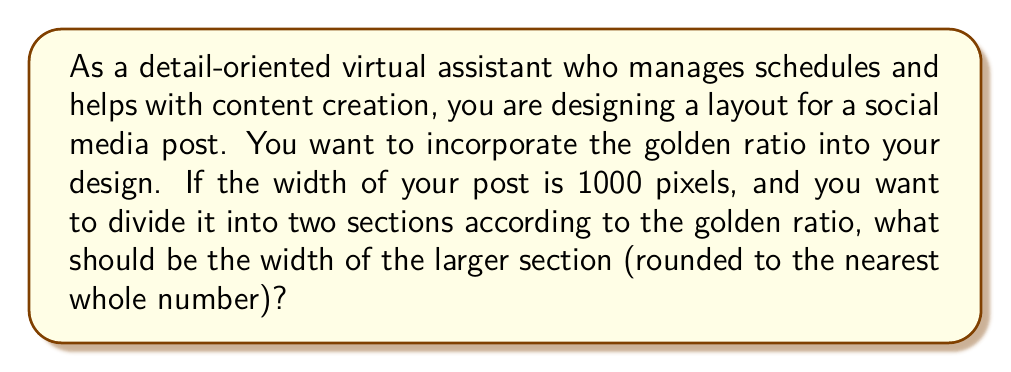Teach me how to tackle this problem. To solve this problem, we need to understand and apply the golden ratio concept:

1. The golden ratio, denoted by φ (phi), is approximately equal to 1.618033988749895.

2. In a golden ratio division, the ratio of the larger part to the smaller part is equal to the ratio of the whole to the larger part. Mathematically, this can be expressed as:

   $$\frac{a}{b} = \frac{a+b}{a} = φ$$

   Where $a$ is the larger part and $b$ is the smaller part.

3. Given that the total width is 1000 pixels, we can set up the equation:

   $$\frac{a}{1000-a} = φ$$

4. Solving for $a$:

   $$a = 1000φ - aφ$$
   $$a + aφ = 1000φ$$
   $$a(1 + φ) = 1000φ$$
   $$a = \frac{1000φ}{1 + φ}$$

5. Substituting the value of φ:

   $$a = \frac{1000 * 1.618033988749895}{1 + 1.618033988749895}$$
   $$a = \frac{1618.033988749895}{2.618033988749895}$$
   $$a ≈ 618.0339887498948$$

6. Rounding to the nearest whole number:

   $a ≈ 618$ pixels

Therefore, the width of the larger section should be 618 pixels.
Answer: 618 pixels 